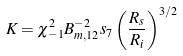Convert formula to latex. <formula><loc_0><loc_0><loc_500><loc_500>K = \chi _ { - 1 } ^ { 2 } B _ { m , 1 2 } ^ { - 2 } s _ { 7 } \left ( \frac { R _ { s } } { R _ { i } } \right ) ^ { 3 / 2 }</formula> 